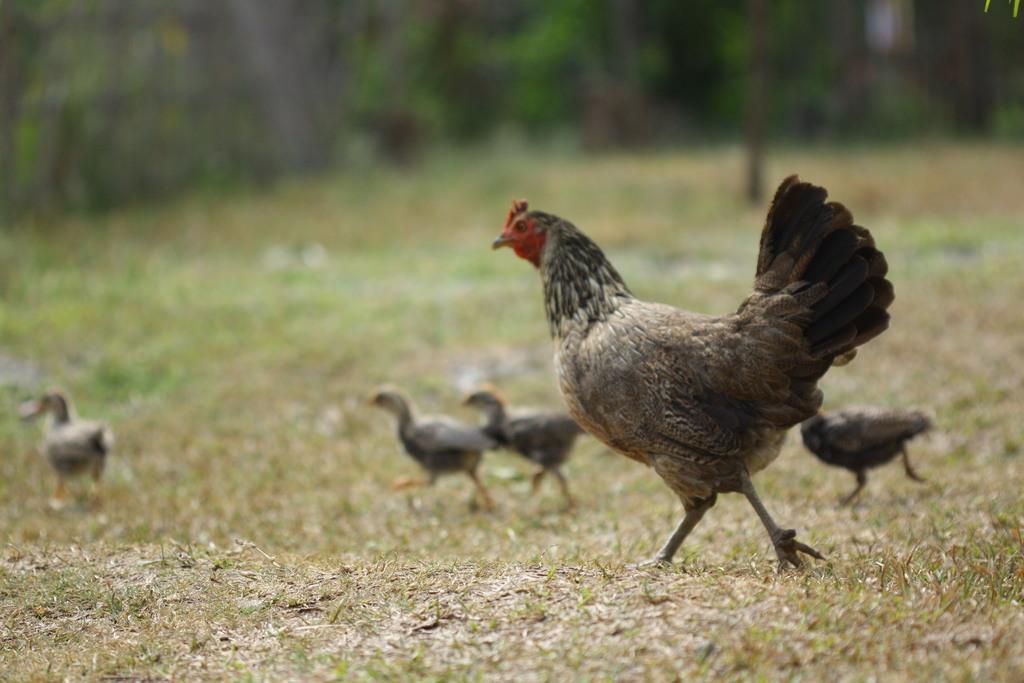Can you describe this image briefly? This image is clicked outside. There are hens in the middle. They are of different size. 